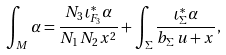Convert formula to latex. <formula><loc_0><loc_0><loc_500><loc_500>\int _ { M } \alpha = \frac { N _ { 3 } \, \iota _ { F _ { 3 } } ^ { * } \alpha } { N _ { 1 } \, N _ { 2 } \, x ^ { 2 } } + \int _ { \Sigma } \frac { \iota _ { \Sigma } ^ { * } \alpha } { b _ { \Sigma } \, u + x } ,</formula> 